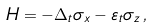Convert formula to latex. <formula><loc_0><loc_0><loc_500><loc_500>H = - \Delta _ { t } \sigma _ { x } - \varepsilon _ { t } \sigma _ { z } \, ,</formula> 